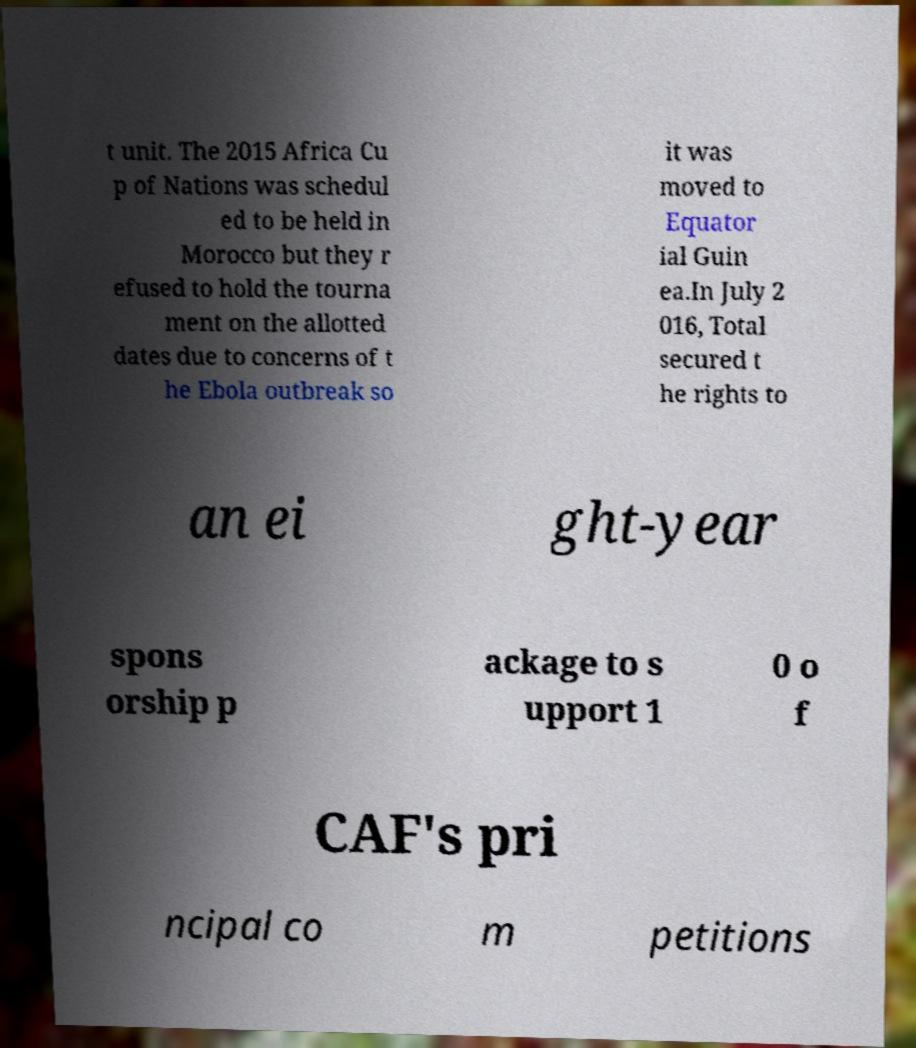There's text embedded in this image that I need extracted. Can you transcribe it verbatim? t unit. The 2015 Africa Cu p of Nations was schedul ed to be held in Morocco but they r efused to hold the tourna ment on the allotted dates due to concerns of t he Ebola outbreak so it was moved to Equator ial Guin ea.In July 2 016, Total secured t he rights to an ei ght-year spons orship p ackage to s upport 1 0 o f CAF's pri ncipal co m petitions 